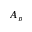Convert formula to latex. <formula><loc_0><loc_0><loc_500><loc_500>A _ { p }</formula> 